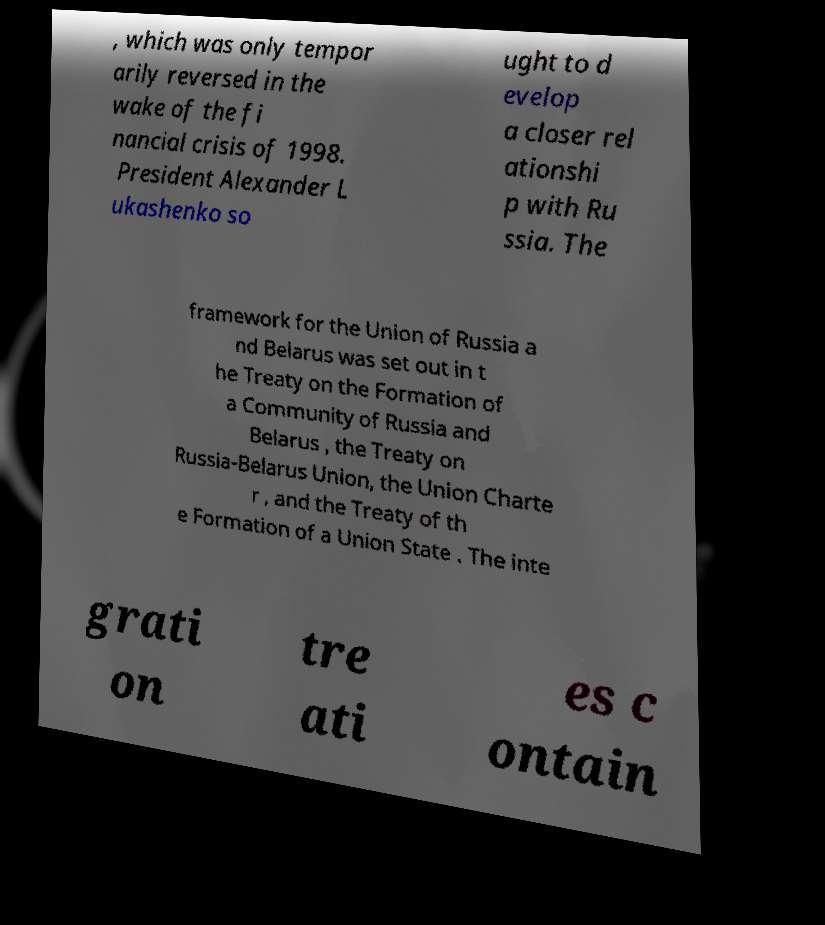Please read and relay the text visible in this image. What does it say? , which was only tempor arily reversed in the wake of the fi nancial crisis of 1998. President Alexander L ukashenko so ught to d evelop a closer rel ationshi p with Ru ssia. The framework for the Union of Russia a nd Belarus was set out in t he Treaty on the Formation of a Community of Russia and Belarus , the Treaty on Russia-Belarus Union, the Union Charte r , and the Treaty of th e Formation of a Union State . The inte grati on tre ati es c ontain 